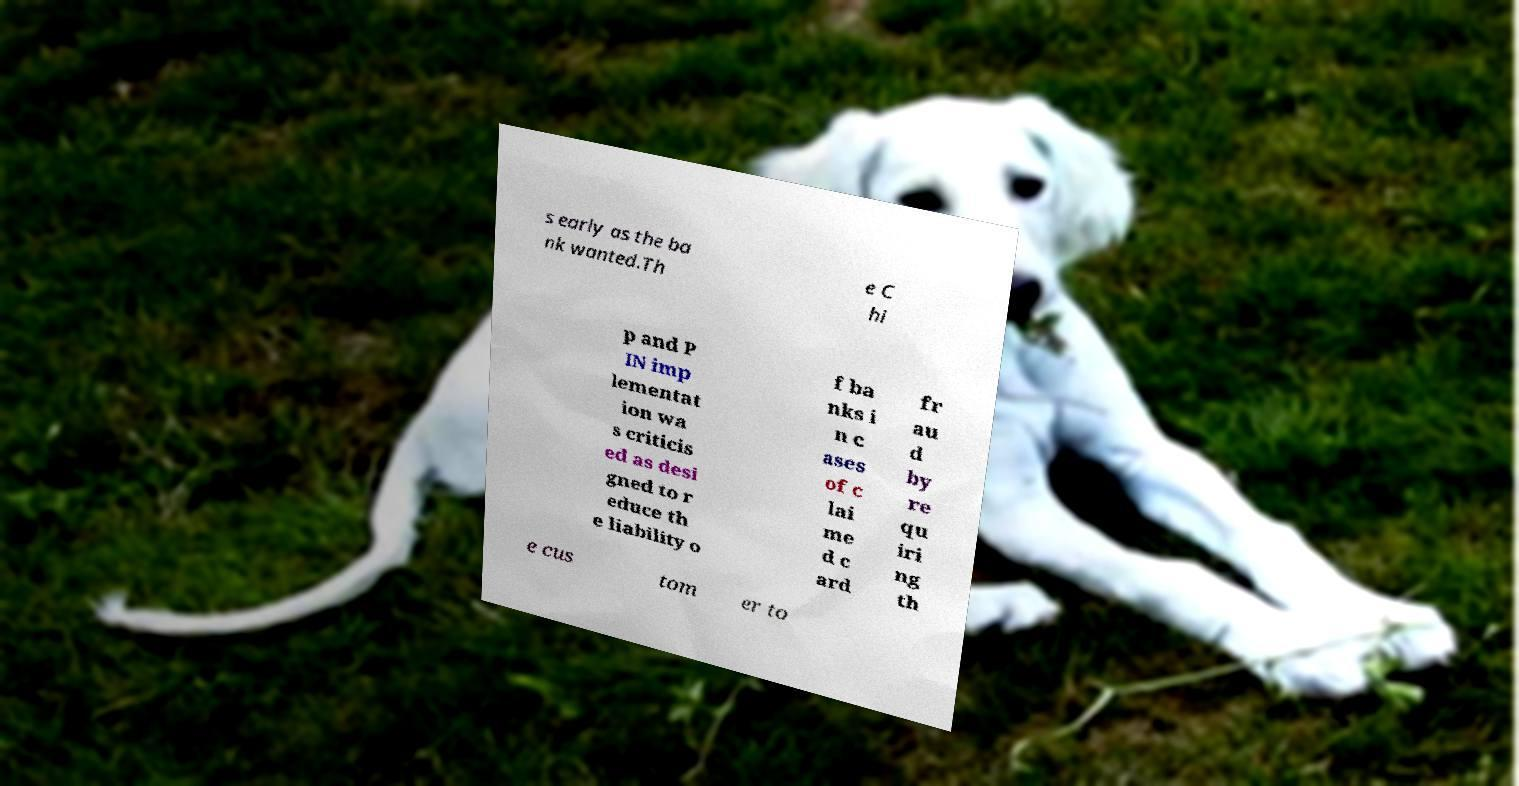Please read and relay the text visible in this image. What does it say? s early as the ba nk wanted.Th e C hi p and P IN imp lementat ion wa s criticis ed as desi gned to r educe th e liability o f ba nks i n c ases of c lai me d c ard fr au d by re qu iri ng th e cus tom er to 